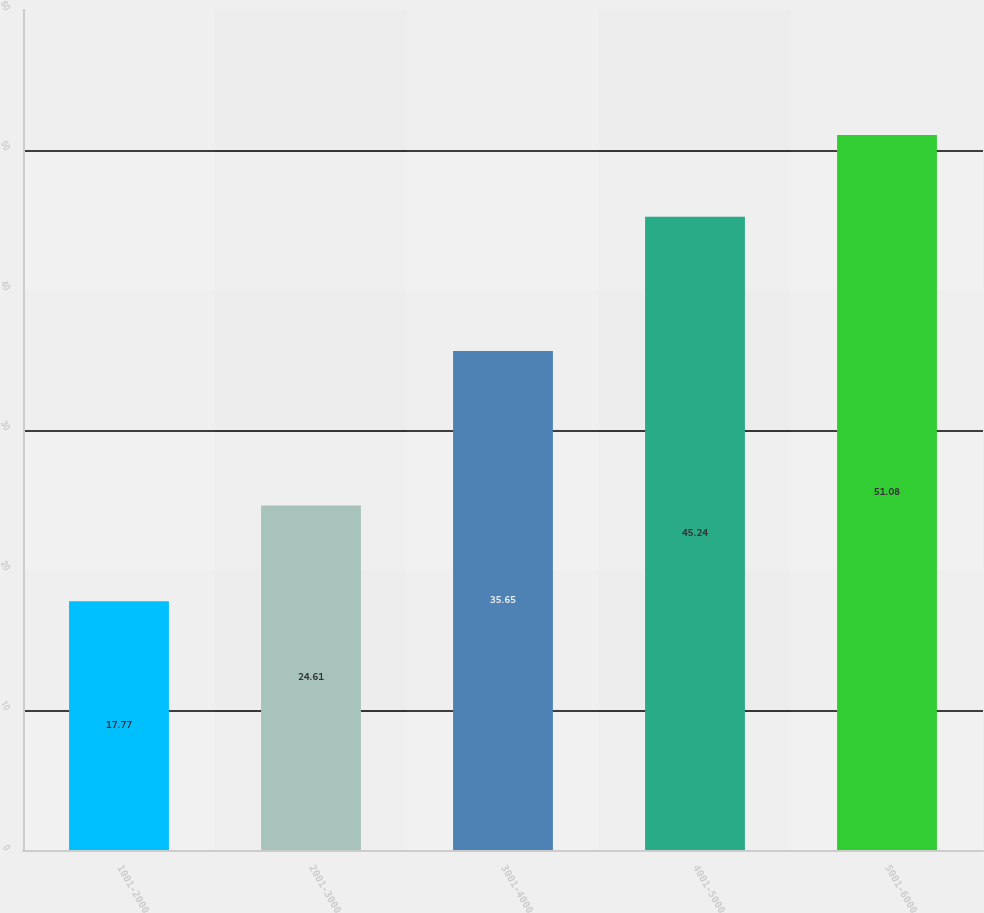Convert chart to OTSL. <chart><loc_0><loc_0><loc_500><loc_500><bar_chart><fcel>1001-2000<fcel>2001-3000<fcel>3001-4000<fcel>4001-5000<fcel>5001-6000<nl><fcel>17.77<fcel>24.61<fcel>35.65<fcel>45.24<fcel>51.08<nl></chart> 